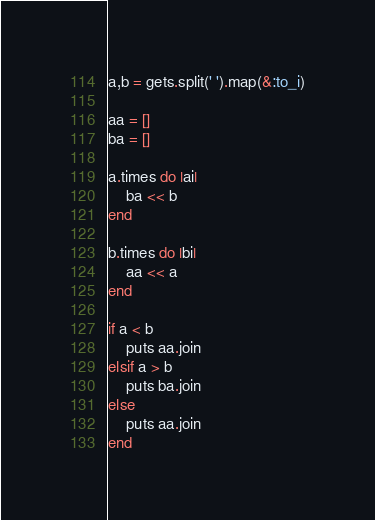<code> <loc_0><loc_0><loc_500><loc_500><_Ruby_>a,b = gets.split(' ').map(&:to_i)

aa = []
ba = []

a.times do |ai|
	ba << b
end

b.times do |bi|
	aa << a	
end

if a < b
	puts aa.join
elsif a > b
	puts ba.join
else
	puts aa.join
end</code> 